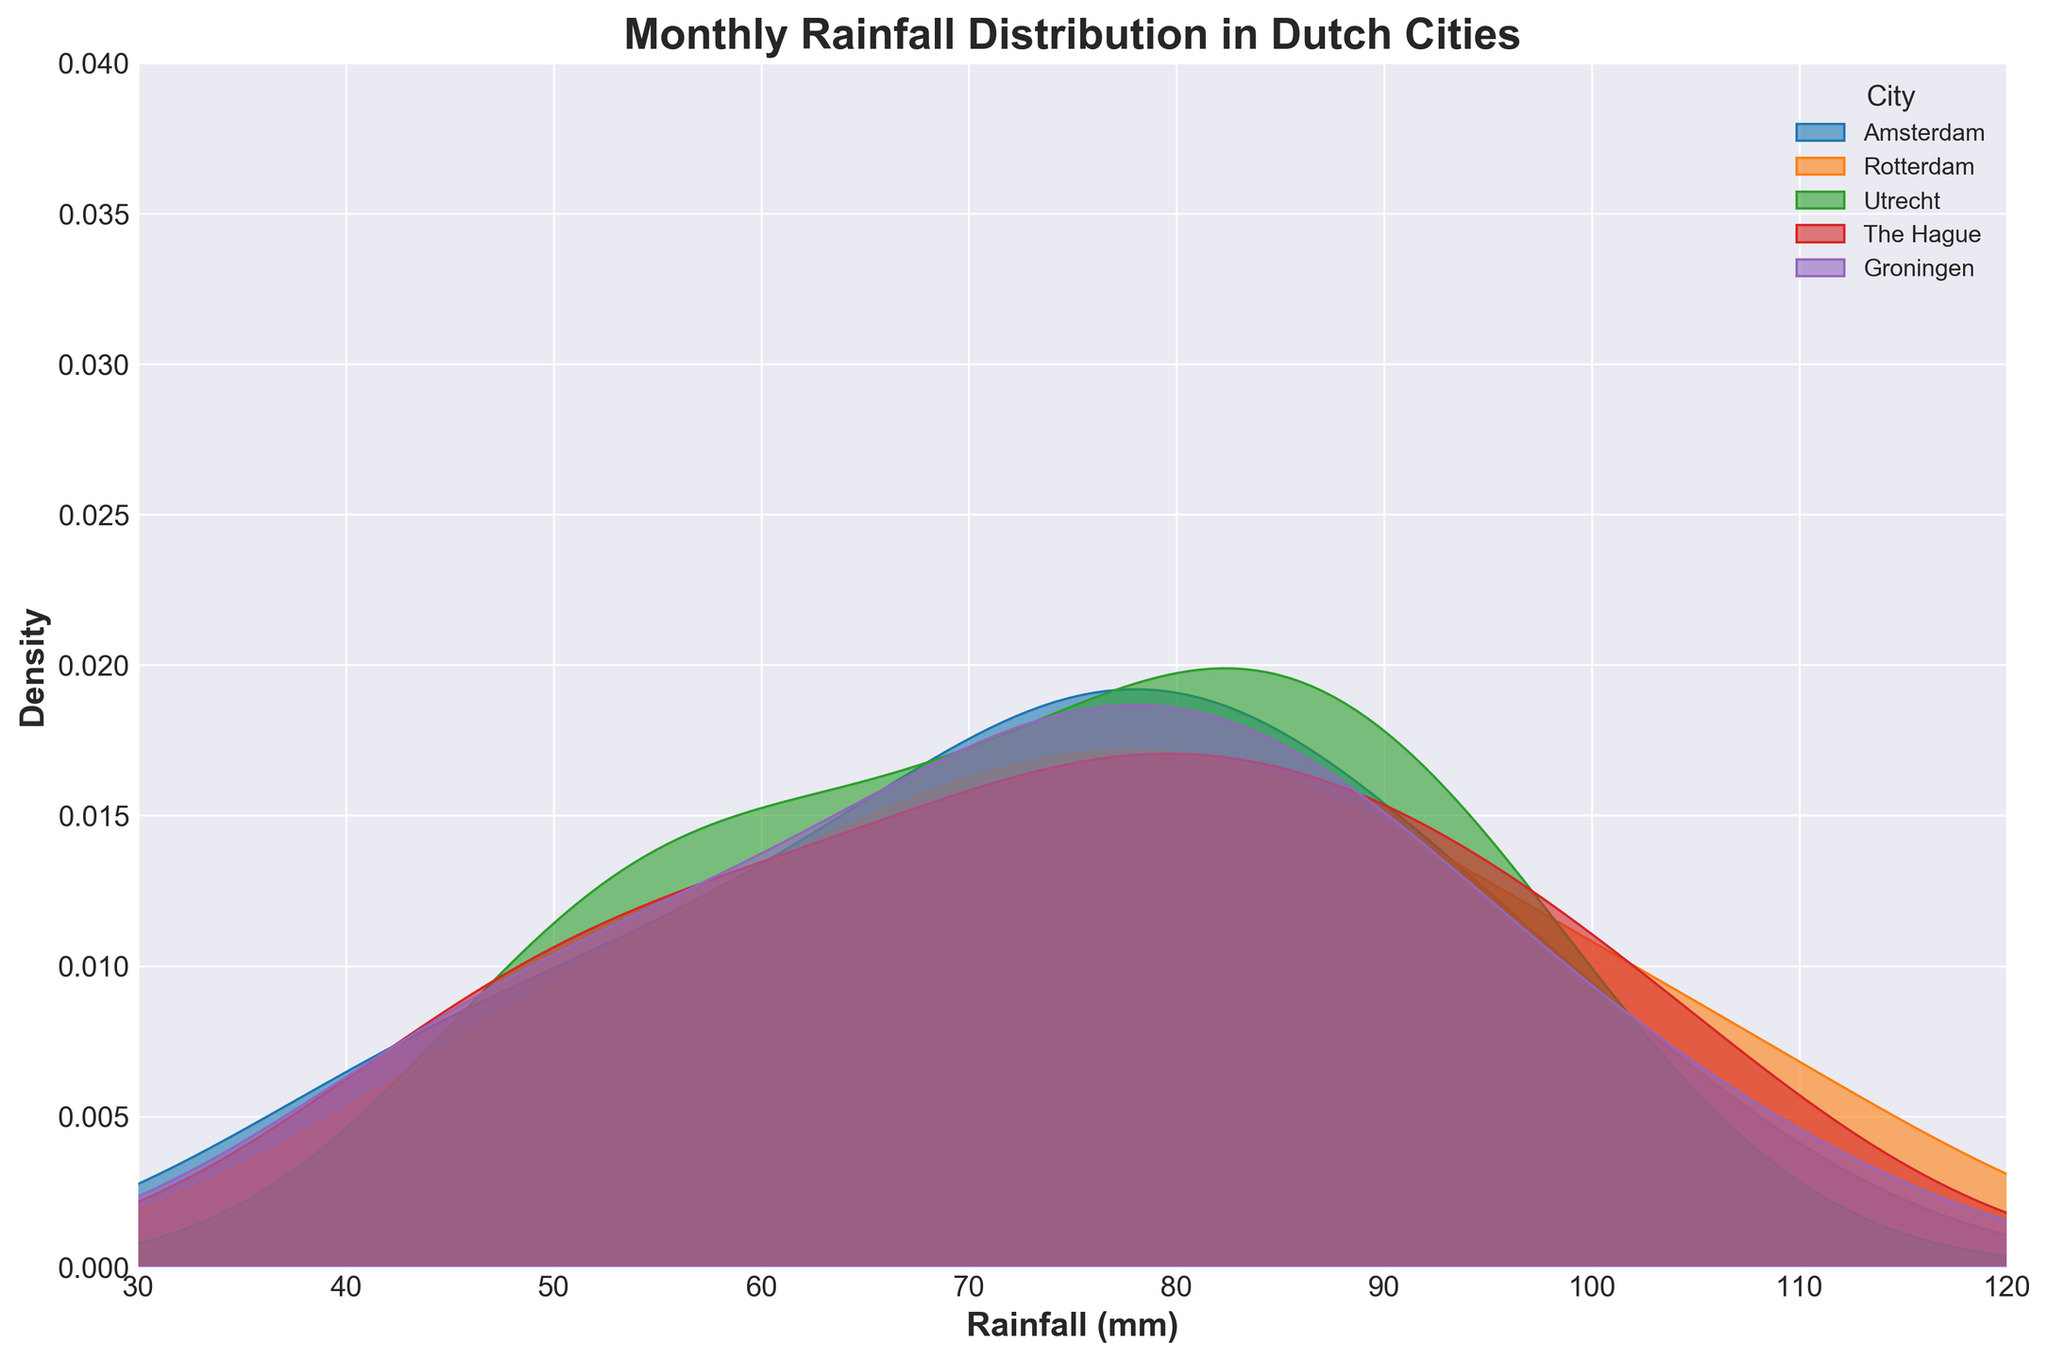What is the title of the plot? The title of the plot is displayed at the top, indicating the main subject of the visualization. In this case, it reads 'Monthly Rainfall Distribution in Dutch Cities'.
Answer: Monthly Rainfall Distribution in Dutch Cities What are the x-axis and y-axis labels in the plot? The x-axis and y-axis labels are the descriptive text that explain what each axis represents. In this case, 'Rainfall (mm)' is the label for the x-axis, and 'Density' is the label for the y-axis.
Answer: x-axis: Rainfall (mm), y-axis: Density Which city has the highest peak in monthly rainfall density? To find the city with the highest peak in the density plot, look for the curve with the highest point. Upon inspection, The Hague has the highest peak.
Answer: The Hague Between which range does the x-axis (Rainfall in mm) extend? The x-axis represents the monthly rainfall in mm, and the range is explicitly set within the plot. The x-axis extends from 30 mm to 120 mm.
Answer: 30 mm to 120 mm Which city shows the widest spread in monthly rainfall distribution? The city with the widest spread will have the flattest and most spread-out density curve. Upon examining the plot, it appears that Rotterdam shows the widest spread in monthly rainfall distribution.
Answer: Rotterdam How does the distribution of monthly rainfall in Amsterdam compare to Groningen? To compare the distributions, look at the shapes and peaks of the density curves for Amsterdam and Groningen. Amsterdam's distribution has a more pronounced peak around 75-85 mm, suggesting common rainfall amounts, whereas Groningen's distribution is slightly broader around the same range but less peaked.
Answer: Amsterdam has a higher peak, Groningen is broader What is the approximate peak density value for Utrecht? The peak density value for each city will be the highest point of their respective density curve. For Utrecht, the highest point on the density curve is around 0.022.
Answer: 0.022 In which rainfall range does The Hague have the majority of its rainfall? The majority density appears where the curve is the highest. For The Hague, the curve peaks around the 70-90 mm range, indicating that this is where most of the rainfall data lies.
Answer: 70-90 mm If you average the peak locations of Amsterdam and Utrecht, what is the value? The peak for Amsterdam is around 80 mm, and for Utrecht, it is around 85 mm. The average of these two would be (80 + 85)/2 = 82.5 mm.
Answer: 82.5 mm Which city has the most similar rainfall distribution to Rotterdam? To find the most similar distribution, compare the heights and shapes of the density curves. Utrecht and Rotterdam share similar peaks and spread of their rainfall distributions, which suggests they are most alike.
Answer: Utrecht 